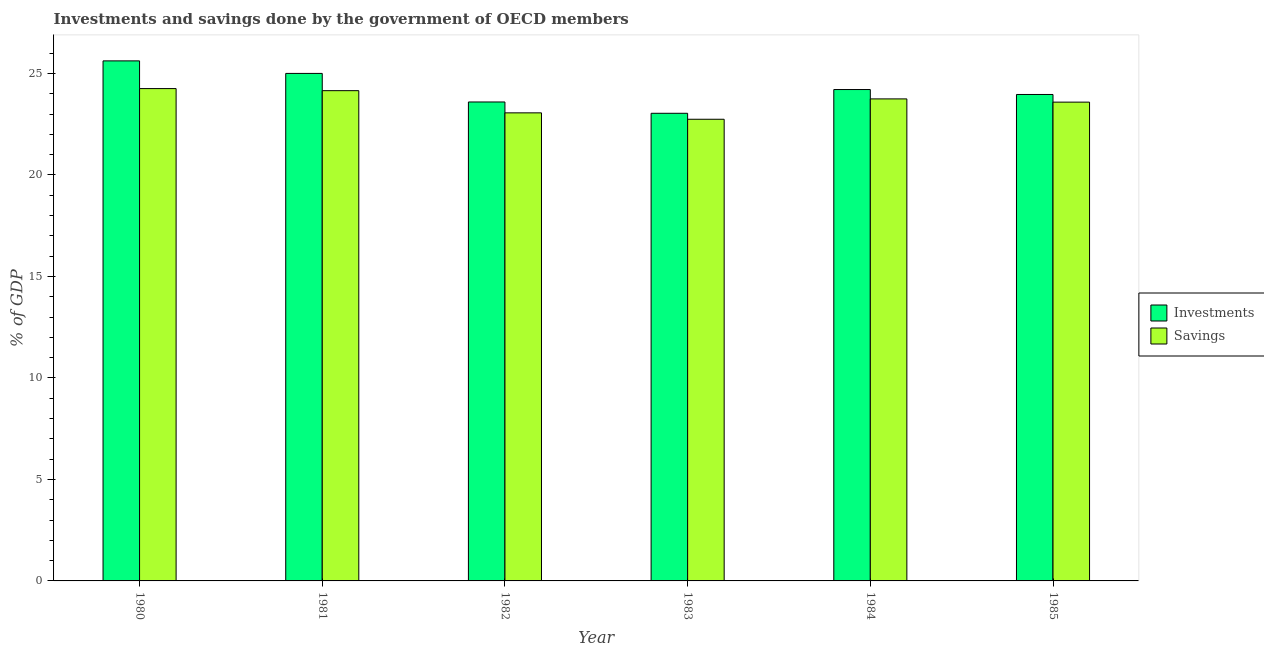How many groups of bars are there?
Give a very brief answer. 6. Are the number of bars on each tick of the X-axis equal?
Offer a very short reply. Yes. How many bars are there on the 1st tick from the left?
Offer a terse response. 2. How many bars are there on the 4th tick from the right?
Make the answer very short. 2. What is the investments of government in 1980?
Keep it short and to the point. 25.62. Across all years, what is the maximum investments of government?
Provide a succinct answer. 25.62. Across all years, what is the minimum savings of government?
Make the answer very short. 22.74. In which year was the savings of government maximum?
Provide a short and direct response. 1980. In which year was the savings of government minimum?
Your response must be concise. 1983. What is the total savings of government in the graph?
Keep it short and to the point. 141.53. What is the difference between the savings of government in 1980 and that in 1982?
Keep it short and to the point. 1.2. What is the difference between the savings of government in 1985 and the investments of government in 1983?
Make the answer very short. 0.84. What is the average savings of government per year?
Offer a terse response. 23.59. What is the ratio of the investments of government in 1983 to that in 1985?
Ensure brevity in your answer.  0.96. What is the difference between the highest and the second highest savings of government?
Your answer should be very brief. 0.1. What is the difference between the highest and the lowest savings of government?
Provide a short and direct response. 1.51. Is the sum of the investments of government in 1980 and 1984 greater than the maximum savings of government across all years?
Your response must be concise. Yes. What does the 1st bar from the left in 1982 represents?
Make the answer very short. Investments. What does the 2nd bar from the right in 1980 represents?
Make the answer very short. Investments. How many years are there in the graph?
Keep it short and to the point. 6. What is the difference between two consecutive major ticks on the Y-axis?
Provide a short and direct response. 5. Does the graph contain any zero values?
Your response must be concise. No. Where does the legend appear in the graph?
Give a very brief answer. Center right. How many legend labels are there?
Ensure brevity in your answer.  2. What is the title of the graph?
Make the answer very short. Investments and savings done by the government of OECD members. Does "Highest 20% of population" appear as one of the legend labels in the graph?
Ensure brevity in your answer.  No. What is the label or title of the Y-axis?
Ensure brevity in your answer.  % of GDP. What is the % of GDP of Investments in 1980?
Keep it short and to the point. 25.62. What is the % of GDP in Savings in 1980?
Provide a short and direct response. 24.25. What is the % of GDP of Investments in 1981?
Your response must be concise. 25. What is the % of GDP of Savings in 1981?
Keep it short and to the point. 24.15. What is the % of GDP of Investments in 1982?
Keep it short and to the point. 23.59. What is the % of GDP in Savings in 1982?
Your answer should be very brief. 23.06. What is the % of GDP in Investments in 1983?
Keep it short and to the point. 23.03. What is the % of GDP of Savings in 1983?
Give a very brief answer. 22.74. What is the % of GDP in Investments in 1984?
Offer a terse response. 24.21. What is the % of GDP of Savings in 1984?
Your answer should be compact. 23.74. What is the % of GDP of Investments in 1985?
Offer a very short reply. 23.96. What is the % of GDP in Savings in 1985?
Your response must be concise. 23.58. Across all years, what is the maximum % of GDP in Investments?
Make the answer very short. 25.62. Across all years, what is the maximum % of GDP of Savings?
Your response must be concise. 24.25. Across all years, what is the minimum % of GDP in Investments?
Your answer should be compact. 23.03. Across all years, what is the minimum % of GDP in Savings?
Offer a very short reply. 22.74. What is the total % of GDP of Investments in the graph?
Your response must be concise. 145.41. What is the total % of GDP of Savings in the graph?
Offer a very short reply. 141.53. What is the difference between the % of GDP in Investments in 1980 and that in 1981?
Give a very brief answer. 0.62. What is the difference between the % of GDP of Savings in 1980 and that in 1981?
Your response must be concise. 0.1. What is the difference between the % of GDP of Investments in 1980 and that in 1982?
Your answer should be very brief. 2.02. What is the difference between the % of GDP in Savings in 1980 and that in 1982?
Give a very brief answer. 1.2. What is the difference between the % of GDP in Investments in 1980 and that in 1983?
Give a very brief answer. 2.58. What is the difference between the % of GDP in Savings in 1980 and that in 1983?
Offer a very short reply. 1.51. What is the difference between the % of GDP in Investments in 1980 and that in 1984?
Your answer should be very brief. 1.41. What is the difference between the % of GDP of Savings in 1980 and that in 1984?
Keep it short and to the point. 0.51. What is the difference between the % of GDP of Investments in 1980 and that in 1985?
Your answer should be very brief. 1.65. What is the difference between the % of GDP of Savings in 1980 and that in 1985?
Make the answer very short. 0.67. What is the difference between the % of GDP of Investments in 1981 and that in 1982?
Provide a short and direct response. 1.41. What is the difference between the % of GDP in Savings in 1981 and that in 1982?
Provide a short and direct response. 1.09. What is the difference between the % of GDP of Investments in 1981 and that in 1983?
Provide a succinct answer. 1.96. What is the difference between the % of GDP of Savings in 1981 and that in 1983?
Your response must be concise. 1.41. What is the difference between the % of GDP in Investments in 1981 and that in 1984?
Your answer should be very brief. 0.79. What is the difference between the % of GDP of Savings in 1981 and that in 1984?
Keep it short and to the point. 0.41. What is the difference between the % of GDP in Investments in 1981 and that in 1985?
Give a very brief answer. 1.04. What is the difference between the % of GDP of Savings in 1981 and that in 1985?
Make the answer very short. 0.56. What is the difference between the % of GDP in Investments in 1982 and that in 1983?
Offer a very short reply. 0.56. What is the difference between the % of GDP in Savings in 1982 and that in 1983?
Your answer should be compact. 0.32. What is the difference between the % of GDP of Investments in 1982 and that in 1984?
Your answer should be very brief. -0.61. What is the difference between the % of GDP in Savings in 1982 and that in 1984?
Offer a terse response. -0.69. What is the difference between the % of GDP of Investments in 1982 and that in 1985?
Your answer should be compact. -0.37. What is the difference between the % of GDP in Savings in 1982 and that in 1985?
Offer a very short reply. -0.53. What is the difference between the % of GDP of Investments in 1983 and that in 1984?
Provide a succinct answer. -1.17. What is the difference between the % of GDP in Savings in 1983 and that in 1984?
Provide a short and direct response. -1. What is the difference between the % of GDP in Investments in 1983 and that in 1985?
Offer a terse response. -0.93. What is the difference between the % of GDP in Savings in 1983 and that in 1985?
Offer a very short reply. -0.84. What is the difference between the % of GDP in Investments in 1984 and that in 1985?
Offer a terse response. 0.24. What is the difference between the % of GDP of Savings in 1984 and that in 1985?
Keep it short and to the point. 0.16. What is the difference between the % of GDP in Investments in 1980 and the % of GDP in Savings in 1981?
Your response must be concise. 1.47. What is the difference between the % of GDP in Investments in 1980 and the % of GDP in Savings in 1982?
Give a very brief answer. 2.56. What is the difference between the % of GDP in Investments in 1980 and the % of GDP in Savings in 1983?
Offer a terse response. 2.88. What is the difference between the % of GDP of Investments in 1980 and the % of GDP of Savings in 1984?
Give a very brief answer. 1.87. What is the difference between the % of GDP of Investments in 1980 and the % of GDP of Savings in 1985?
Offer a terse response. 2.03. What is the difference between the % of GDP in Investments in 1981 and the % of GDP in Savings in 1982?
Provide a succinct answer. 1.94. What is the difference between the % of GDP in Investments in 1981 and the % of GDP in Savings in 1983?
Offer a very short reply. 2.26. What is the difference between the % of GDP in Investments in 1981 and the % of GDP in Savings in 1984?
Provide a succinct answer. 1.26. What is the difference between the % of GDP of Investments in 1981 and the % of GDP of Savings in 1985?
Provide a succinct answer. 1.41. What is the difference between the % of GDP in Investments in 1982 and the % of GDP in Savings in 1983?
Provide a short and direct response. 0.85. What is the difference between the % of GDP in Investments in 1982 and the % of GDP in Savings in 1984?
Ensure brevity in your answer.  -0.15. What is the difference between the % of GDP of Investments in 1982 and the % of GDP of Savings in 1985?
Provide a succinct answer. 0.01. What is the difference between the % of GDP in Investments in 1983 and the % of GDP in Savings in 1984?
Offer a terse response. -0.71. What is the difference between the % of GDP in Investments in 1983 and the % of GDP in Savings in 1985?
Provide a succinct answer. -0.55. What is the difference between the % of GDP of Investments in 1984 and the % of GDP of Savings in 1985?
Make the answer very short. 0.62. What is the average % of GDP of Investments per year?
Provide a short and direct response. 24.24. What is the average % of GDP in Savings per year?
Give a very brief answer. 23.59. In the year 1980, what is the difference between the % of GDP of Investments and % of GDP of Savings?
Offer a terse response. 1.36. In the year 1981, what is the difference between the % of GDP of Investments and % of GDP of Savings?
Make the answer very short. 0.85. In the year 1982, what is the difference between the % of GDP of Investments and % of GDP of Savings?
Your answer should be very brief. 0.54. In the year 1983, what is the difference between the % of GDP in Investments and % of GDP in Savings?
Give a very brief answer. 0.29. In the year 1984, what is the difference between the % of GDP of Investments and % of GDP of Savings?
Provide a short and direct response. 0.46. In the year 1985, what is the difference between the % of GDP of Investments and % of GDP of Savings?
Ensure brevity in your answer.  0.38. What is the ratio of the % of GDP in Investments in 1980 to that in 1981?
Your answer should be very brief. 1.02. What is the ratio of the % of GDP in Investments in 1980 to that in 1982?
Your answer should be very brief. 1.09. What is the ratio of the % of GDP in Savings in 1980 to that in 1982?
Make the answer very short. 1.05. What is the ratio of the % of GDP in Investments in 1980 to that in 1983?
Provide a succinct answer. 1.11. What is the ratio of the % of GDP of Savings in 1980 to that in 1983?
Your answer should be very brief. 1.07. What is the ratio of the % of GDP of Investments in 1980 to that in 1984?
Keep it short and to the point. 1.06. What is the ratio of the % of GDP in Savings in 1980 to that in 1984?
Keep it short and to the point. 1.02. What is the ratio of the % of GDP of Investments in 1980 to that in 1985?
Your response must be concise. 1.07. What is the ratio of the % of GDP of Savings in 1980 to that in 1985?
Your answer should be very brief. 1.03. What is the ratio of the % of GDP of Investments in 1981 to that in 1982?
Give a very brief answer. 1.06. What is the ratio of the % of GDP in Savings in 1981 to that in 1982?
Your answer should be very brief. 1.05. What is the ratio of the % of GDP in Investments in 1981 to that in 1983?
Give a very brief answer. 1.09. What is the ratio of the % of GDP in Savings in 1981 to that in 1983?
Ensure brevity in your answer.  1.06. What is the ratio of the % of GDP of Investments in 1981 to that in 1984?
Keep it short and to the point. 1.03. What is the ratio of the % of GDP in Savings in 1981 to that in 1984?
Ensure brevity in your answer.  1.02. What is the ratio of the % of GDP in Investments in 1981 to that in 1985?
Offer a terse response. 1.04. What is the ratio of the % of GDP of Savings in 1981 to that in 1985?
Give a very brief answer. 1.02. What is the ratio of the % of GDP of Investments in 1982 to that in 1983?
Keep it short and to the point. 1.02. What is the ratio of the % of GDP of Savings in 1982 to that in 1983?
Your answer should be compact. 1.01. What is the ratio of the % of GDP of Investments in 1982 to that in 1984?
Keep it short and to the point. 0.97. What is the ratio of the % of GDP of Savings in 1982 to that in 1984?
Your answer should be compact. 0.97. What is the ratio of the % of GDP of Investments in 1982 to that in 1985?
Your answer should be very brief. 0.98. What is the ratio of the % of GDP in Savings in 1982 to that in 1985?
Your answer should be compact. 0.98. What is the ratio of the % of GDP of Investments in 1983 to that in 1984?
Ensure brevity in your answer.  0.95. What is the ratio of the % of GDP in Savings in 1983 to that in 1984?
Ensure brevity in your answer.  0.96. What is the ratio of the % of GDP in Investments in 1983 to that in 1985?
Keep it short and to the point. 0.96. What is the ratio of the % of GDP of Savings in 1983 to that in 1985?
Provide a succinct answer. 0.96. What is the ratio of the % of GDP in Investments in 1984 to that in 1985?
Provide a short and direct response. 1.01. What is the difference between the highest and the second highest % of GDP of Investments?
Your answer should be compact. 0.62. What is the difference between the highest and the second highest % of GDP in Savings?
Keep it short and to the point. 0.1. What is the difference between the highest and the lowest % of GDP of Investments?
Provide a succinct answer. 2.58. What is the difference between the highest and the lowest % of GDP in Savings?
Offer a terse response. 1.51. 